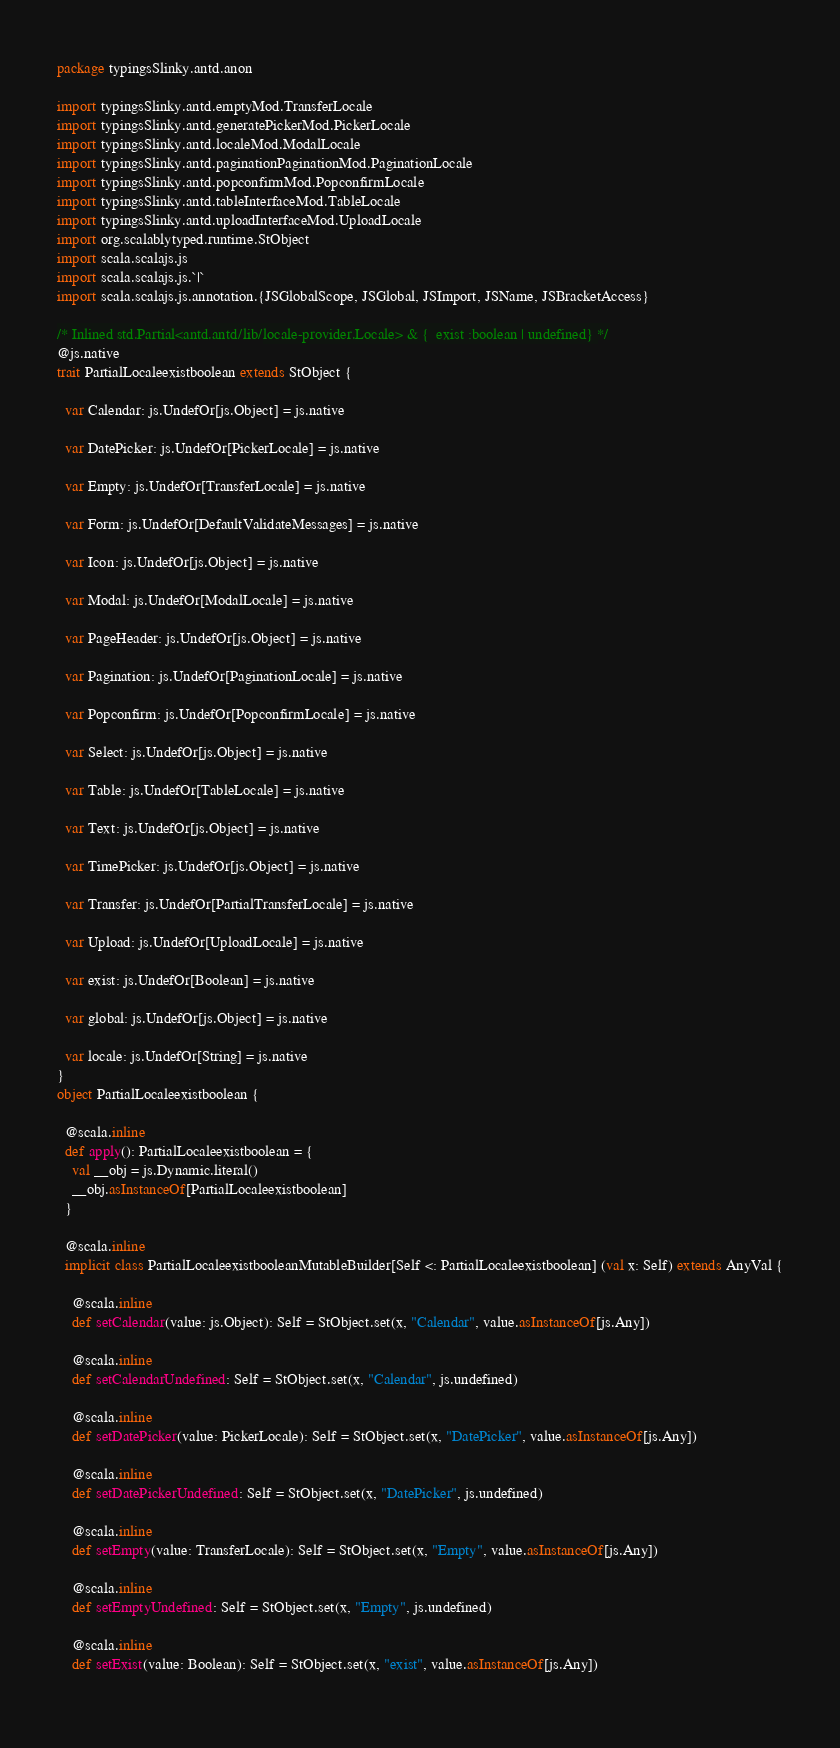Convert code to text. <code><loc_0><loc_0><loc_500><loc_500><_Scala_>package typingsSlinky.antd.anon

import typingsSlinky.antd.emptyMod.TransferLocale
import typingsSlinky.antd.generatePickerMod.PickerLocale
import typingsSlinky.antd.localeMod.ModalLocale
import typingsSlinky.antd.paginationPaginationMod.PaginationLocale
import typingsSlinky.antd.popconfirmMod.PopconfirmLocale
import typingsSlinky.antd.tableInterfaceMod.TableLocale
import typingsSlinky.antd.uploadInterfaceMod.UploadLocale
import org.scalablytyped.runtime.StObject
import scala.scalajs.js
import scala.scalajs.js.`|`
import scala.scalajs.js.annotation.{JSGlobalScope, JSGlobal, JSImport, JSName, JSBracketAccess}

/* Inlined std.Partial<antd.antd/lib/locale-provider.Locale> & {  exist :boolean | undefined} */
@js.native
trait PartialLocaleexistboolean extends StObject {
  
  var Calendar: js.UndefOr[js.Object] = js.native
  
  var DatePicker: js.UndefOr[PickerLocale] = js.native
  
  var Empty: js.UndefOr[TransferLocale] = js.native
  
  var Form: js.UndefOr[DefaultValidateMessages] = js.native
  
  var Icon: js.UndefOr[js.Object] = js.native
  
  var Modal: js.UndefOr[ModalLocale] = js.native
  
  var PageHeader: js.UndefOr[js.Object] = js.native
  
  var Pagination: js.UndefOr[PaginationLocale] = js.native
  
  var Popconfirm: js.UndefOr[PopconfirmLocale] = js.native
  
  var Select: js.UndefOr[js.Object] = js.native
  
  var Table: js.UndefOr[TableLocale] = js.native
  
  var Text: js.UndefOr[js.Object] = js.native
  
  var TimePicker: js.UndefOr[js.Object] = js.native
  
  var Transfer: js.UndefOr[PartialTransferLocale] = js.native
  
  var Upload: js.UndefOr[UploadLocale] = js.native
  
  var exist: js.UndefOr[Boolean] = js.native
  
  var global: js.UndefOr[js.Object] = js.native
  
  var locale: js.UndefOr[String] = js.native
}
object PartialLocaleexistboolean {
  
  @scala.inline
  def apply(): PartialLocaleexistboolean = {
    val __obj = js.Dynamic.literal()
    __obj.asInstanceOf[PartialLocaleexistboolean]
  }
  
  @scala.inline
  implicit class PartialLocaleexistbooleanMutableBuilder[Self <: PartialLocaleexistboolean] (val x: Self) extends AnyVal {
    
    @scala.inline
    def setCalendar(value: js.Object): Self = StObject.set(x, "Calendar", value.asInstanceOf[js.Any])
    
    @scala.inline
    def setCalendarUndefined: Self = StObject.set(x, "Calendar", js.undefined)
    
    @scala.inline
    def setDatePicker(value: PickerLocale): Self = StObject.set(x, "DatePicker", value.asInstanceOf[js.Any])
    
    @scala.inline
    def setDatePickerUndefined: Self = StObject.set(x, "DatePicker", js.undefined)
    
    @scala.inline
    def setEmpty(value: TransferLocale): Self = StObject.set(x, "Empty", value.asInstanceOf[js.Any])
    
    @scala.inline
    def setEmptyUndefined: Self = StObject.set(x, "Empty", js.undefined)
    
    @scala.inline
    def setExist(value: Boolean): Self = StObject.set(x, "exist", value.asInstanceOf[js.Any])
    </code> 